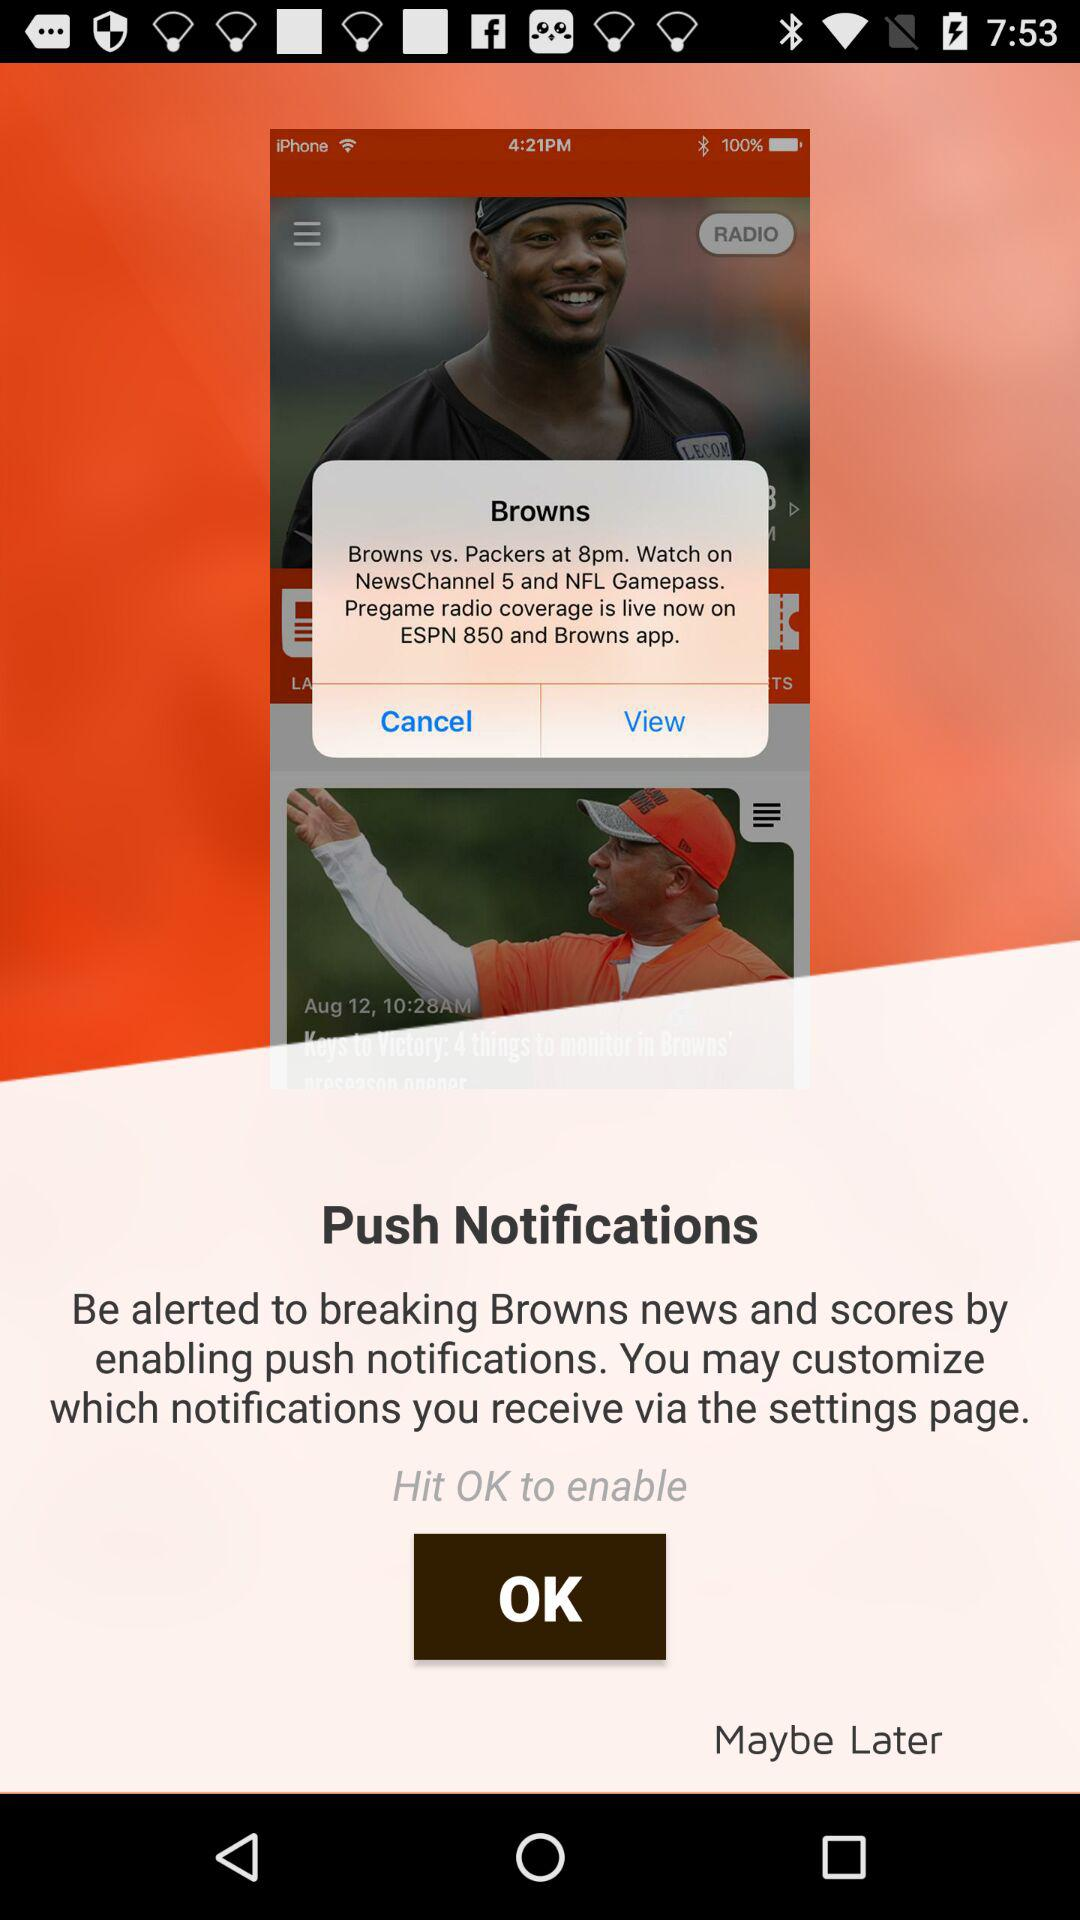What channels will the Browns vs. Packers game be broadcast on? The channels are "NewsChannel 5" and "NFL Gamepass". 